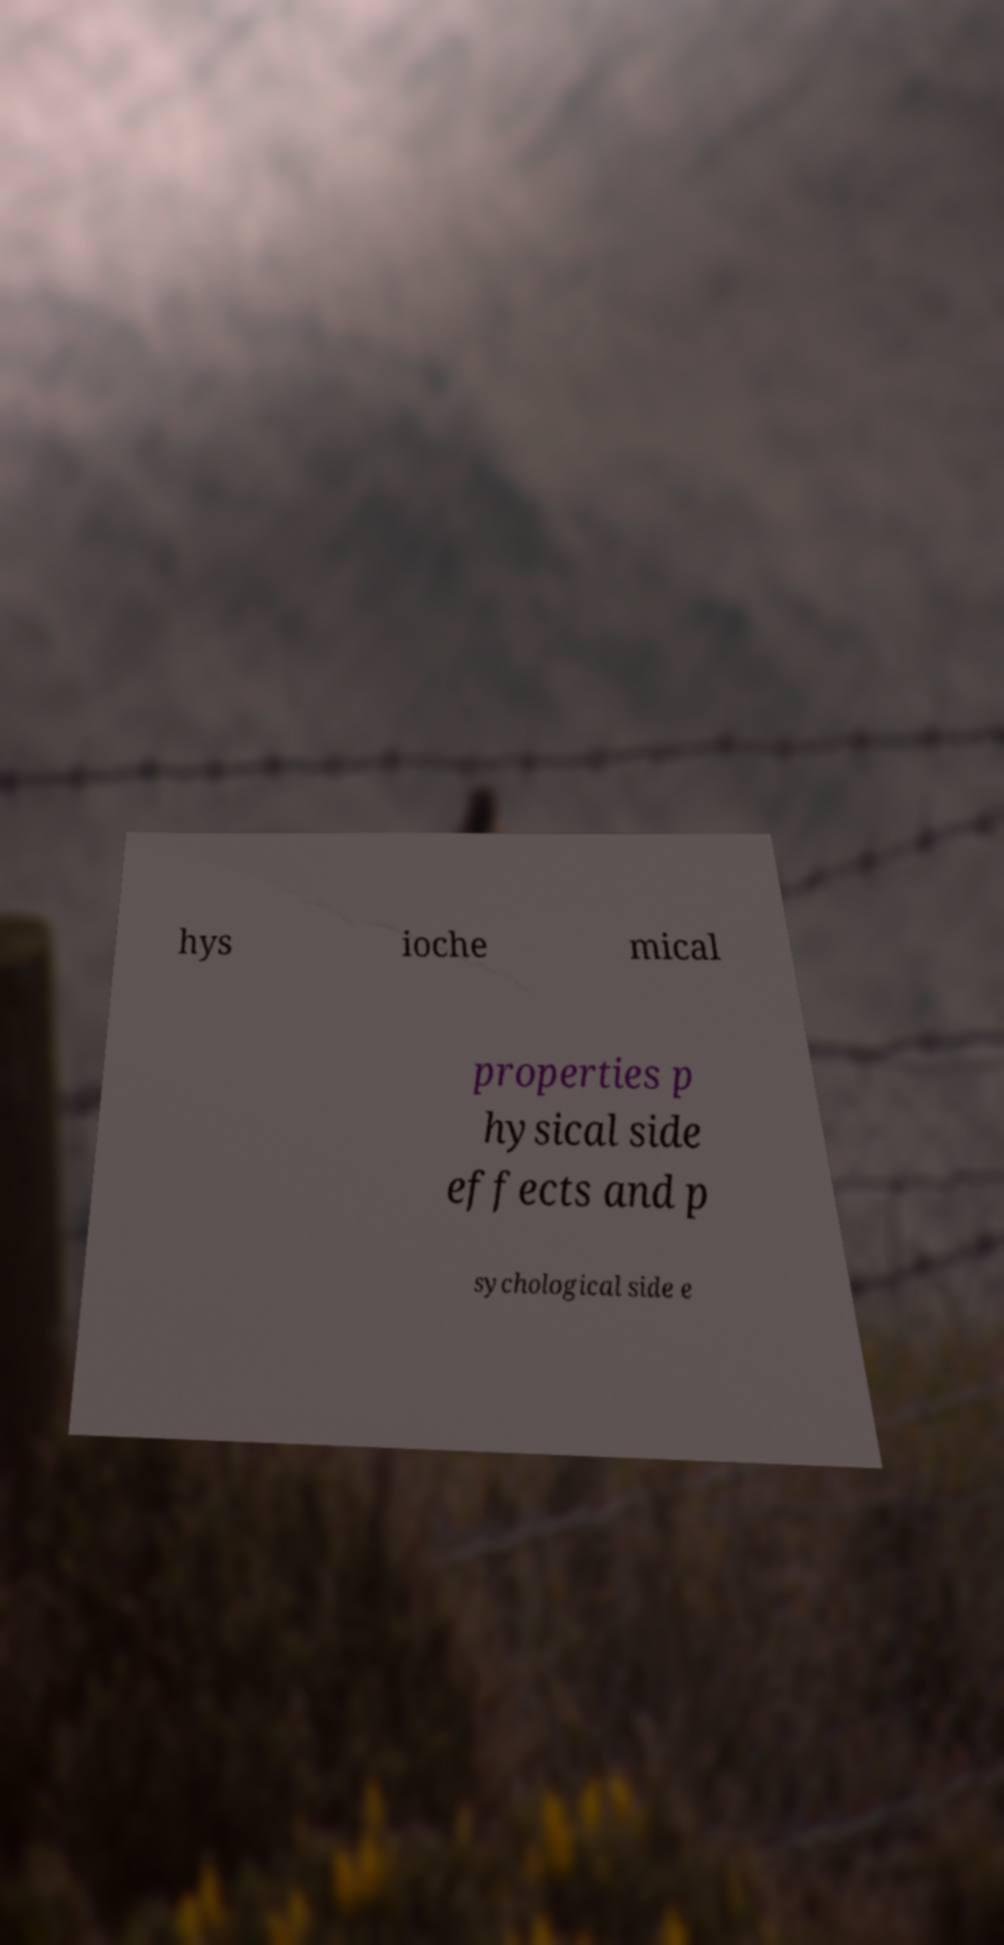Can you accurately transcribe the text from the provided image for me? hys ioche mical properties p hysical side effects and p sychological side e 